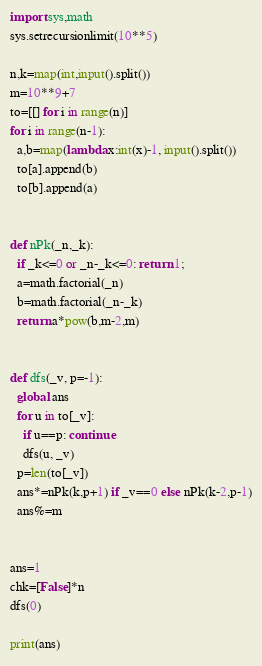Convert code to text. <code><loc_0><loc_0><loc_500><loc_500><_Python_>import sys,math
sys.setrecursionlimit(10**5)

n,k=map(int,input().split())
m=10**9+7
to=[[] for i in range(n)]
for i in range(n-1):
  a,b=map(lambda x:int(x)-1, input().split())
  to[a].append(b)
  to[b].append(a)


def nPk(_n,_k):
  if _k<=0 or _n-_k<=0: return 1;
  a=math.factorial(_n)
  b=math.factorial(_n-_k)
  return a*pow(b,m-2,m)


def dfs(_v, p=-1):
  global ans
  for u in to[_v]:
    if u==p: continue
    dfs(u, _v)
  p=len(to[_v])
  ans*=nPk(k,p+1) if _v==0 else nPk(k-2,p-1)
  ans%=m
    
    
ans=1
chk=[False]*n
dfs(0)
  
print(ans)</code> 